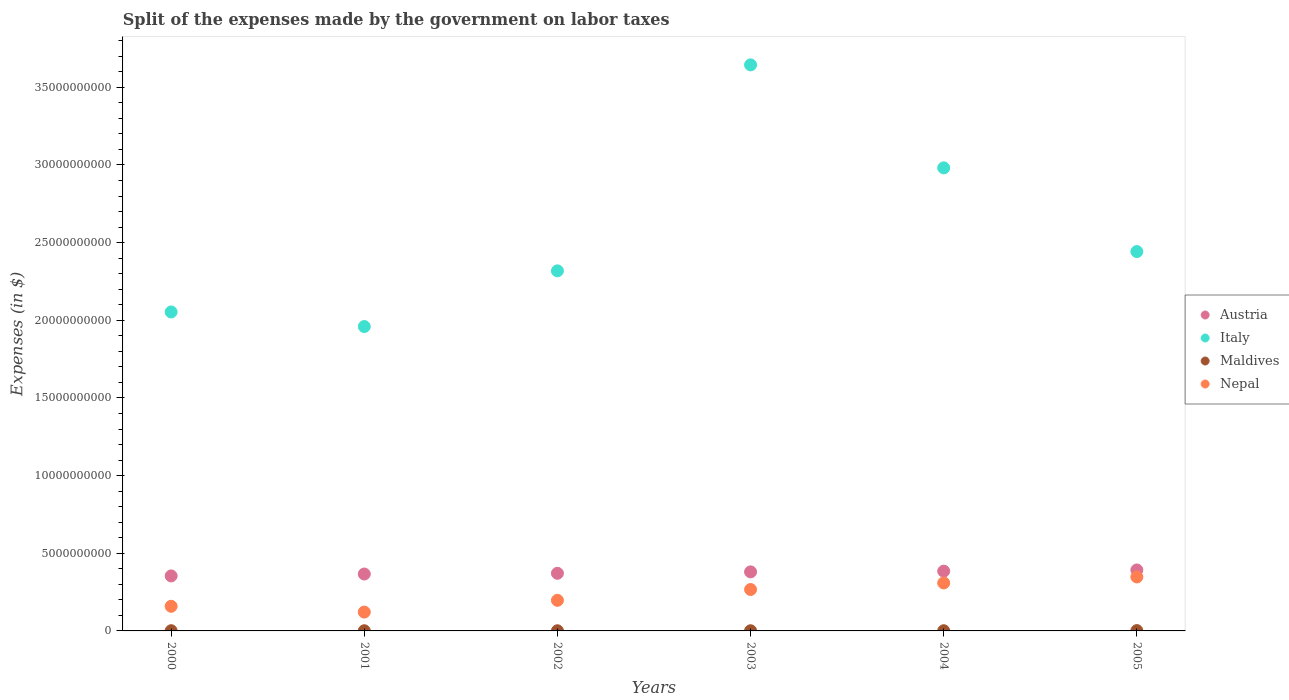How many different coloured dotlines are there?
Your answer should be very brief. 4. What is the expenses made by the government on labor taxes in Maldives in 2004?
Your answer should be compact. 1.22e+07. Across all years, what is the maximum expenses made by the government on labor taxes in Austria?
Offer a terse response. 3.93e+09. Across all years, what is the minimum expenses made by the government on labor taxes in Maldives?
Give a very brief answer. 1.01e+07. In which year was the expenses made by the government on labor taxes in Austria minimum?
Your answer should be very brief. 2000. What is the total expenses made by the government on labor taxes in Austria in the graph?
Your answer should be compact. 2.25e+1. What is the difference between the expenses made by the government on labor taxes in Maldives in 2004 and that in 2005?
Offer a terse response. -8.00e+06. What is the difference between the expenses made by the government on labor taxes in Italy in 2000 and the expenses made by the government on labor taxes in Maldives in 2001?
Offer a very short reply. 2.05e+1. What is the average expenses made by the government on labor taxes in Nepal per year?
Provide a short and direct response. 2.33e+09. In the year 2005, what is the difference between the expenses made by the government on labor taxes in Maldives and expenses made by the government on labor taxes in Nepal?
Ensure brevity in your answer.  -3.45e+09. In how many years, is the expenses made by the government on labor taxes in Austria greater than 12000000000 $?
Your answer should be very brief. 0. What is the ratio of the expenses made by the government on labor taxes in Austria in 2001 to that in 2002?
Make the answer very short. 0.99. Is the expenses made by the government on labor taxes in Italy in 2000 less than that in 2005?
Keep it short and to the point. Yes. What is the difference between the highest and the second highest expenses made by the government on labor taxes in Maldives?
Provide a short and direct response. 6.80e+06. What is the difference between the highest and the lowest expenses made by the government on labor taxes in Maldives?
Your answer should be very brief. 1.01e+07. In how many years, is the expenses made by the government on labor taxes in Nepal greater than the average expenses made by the government on labor taxes in Nepal taken over all years?
Provide a succinct answer. 3. Is it the case that in every year, the sum of the expenses made by the government on labor taxes in Maldives and expenses made by the government on labor taxes in Italy  is greater than the sum of expenses made by the government on labor taxes in Nepal and expenses made by the government on labor taxes in Austria?
Offer a terse response. Yes. Is it the case that in every year, the sum of the expenses made by the government on labor taxes in Austria and expenses made by the government on labor taxes in Italy  is greater than the expenses made by the government on labor taxes in Maldives?
Make the answer very short. Yes. Does the graph contain grids?
Provide a succinct answer. No. How are the legend labels stacked?
Give a very brief answer. Vertical. What is the title of the graph?
Provide a succinct answer. Split of the expenses made by the government on labor taxes. Does "Liechtenstein" appear as one of the legend labels in the graph?
Your answer should be very brief. No. What is the label or title of the X-axis?
Your response must be concise. Years. What is the label or title of the Y-axis?
Offer a very short reply. Expenses (in $). What is the Expenses (in $) of Austria in 2000?
Your answer should be compact. 3.54e+09. What is the Expenses (in $) of Italy in 2000?
Offer a very short reply. 2.05e+1. What is the Expenses (in $) of Maldives in 2000?
Your answer should be very brief. 1.34e+07. What is the Expenses (in $) of Nepal in 2000?
Your response must be concise. 1.59e+09. What is the Expenses (in $) of Austria in 2001?
Offer a terse response. 3.66e+09. What is the Expenses (in $) in Italy in 2001?
Your answer should be compact. 1.96e+1. What is the Expenses (in $) of Maldives in 2001?
Provide a succinct answer. 1.19e+07. What is the Expenses (in $) of Nepal in 2001?
Make the answer very short. 1.21e+09. What is the Expenses (in $) in Austria in 2002?
Your response must be concise. 3.71e+09. What is the Expenses (in $) in Italy in 2002?
Your answer should be compact. 2.32e+1. What is the Expenses (in $) in Maldives in 2002?
Give a very brief answer. 1.01e+07. What is the Expenses (in $) of Nepal in 2002?
Your answer should be very brief. 1.97e+09. What is the Expenses (in $) of Austria in 2003?
Keep it short and to the point. 3.80e+09. What is the Expenses (in $) of Italy in 2003?
Offer a terse response. 3.64e+1. What is the Expenses (in $) in Maldives in 2003?
Keep it short and to the point. 1.06e+07. What is the Expenses (in $) in Nepal in 2003?
Make the answer very short. 2.67e+09. What is the Expenses (in $) in Austria in 2004?
Offer a terse response. 3.85e+09. What is the Expenses (in $) in Italy in 2004?
Your answer should be compact. 2.98e+1. What is the Expenses (in $) in Maldives in 2004?
Provide a succinct answer. 1.22e+07. What is the Expenses (in $) in Nepal in 2004?
Offer a terse response. 3.09e+09. What is the Expenses (in $) in Austria in 2005?
Your answer should be compact. 3.93e+09. What is the Expenses (in $) in Italy in 2005?
Offer a terse response. 2.44e+1. What is the Expenses (in $) in Maldives in 2005?
Keep it short and to the point. 2.02e+07. What is the Expenses (in $) in Nepal in 2005?
Provide a short and direct response. 3.48e+09. Across all years, what is the maximum Expenses (in $) in Austria?
Your response must be concise. 3.93e+09. Across all years, what is the maximum Expenses (in $) in Italy?
Your answer should be compact. 3.64e+1. Across all years, what is the maximum Expenses (in $) in Maldives?
Ensure brevity in your answer.  2.02e+07. Across all years, what is the maximum Expenses (in $) of Nepal?
Offer a very short reply. 3.48e+09. Across all years, what is the minimum Expenses (in $) in Austria?
Keep it short and to the point. 3.54e+09. Across all years, what is the minimum Expenses (in $) of Italy?
Offer a terse response. 1.96e+1. Across all years, what is the minimum Expenses (in $) of Maldives?
Give a very brief answer. 1.01e+07. Across all years, what is the minimum Expenses (in $) of Nepal?
Offer a very short reply. 1.21e+09. What is the total Expenses (in $) in Austria in the graph?
Make the answer very short. 2.25e+1. What is the total Expenses (in $) in Italy in the graph?
Offer a very short reply. 1.54e+11. What is the total Expenses (in $) in Maldives in the graph?
Offer a terse response. 7.84e+07. What is the total Expenses (in $) of Nepal in the graph?
Your response must be concise. 1.40e+1. What is the difference between the Expenses (in $) in Austria in 2000 and that in 2001?
Ensure brevity in your answer.  -1.22e+08. What is the difference between the Expenses (in $) of Italy in 2000 and that in 2001?
Offer a terse response. 9.39e+08. What is the difference between the Expenses (in $) in Maldives in 2000 and that in 2001?
Offer a very short reply. 1.50e+06. What is the difference between the Expenses (in $) of Nepal in 2000 and that in 2001?
Your response must be concise. 3.73e+08. What is the difference between the Expenses (in $) in Austria in 2000 and that in 2002?
Offer a terse response. -1.69e+08. What is the difference between the Expenses (in $) in Italy in 2000 and that in 2002?
Your answer should be very brief. -2.65e+09. What is the difference between the Expenses (in $) of Maldives in 2000 and that in 2002?
Provide a short and direct response. 3.30e+06. What is the difference between the Expenses (in $) in Nepal in 2000 and that in 2002?
Your answer should be very brief. -3.84e+08. What is the difference between the Expenses (in $) in Austria in 2000 and that in 2003?
Keep it short and to the point. -2.60e+08. What is the difference between the Expenses (in $) in Italy in 2000 and that in 2003?
Offer a very short reply. -1.59e+1. What is the difference between the Expenses (in $) of Maldives in 2000 and that in 2003?
Keep it short and to the point. 2.80e+06. What is the difference between the Expenses (in $) of Nepal in 2000 and that in 2003?
Offer a very short reply. -1.08e+09. What is the difference between the Expenses (in $) in Austria in 2000 and that in 2004?
Your response must be concise. -3.06e+08. What is the difference between the Expenses (in $) of Italy in 2000 and that in 2004?
Your answer should be compact. -9.28e+09. What is the difference between the Expenses (in $) of Maldives in 2000 and that in 2004?
Your answer should be very brief. 1.20e+06. What is the difference between the Expenses (in $) in Nepal in 2000 and that in 2004?
Provide a succinct answer. -1.50e+09. What is the difference between the Expenses (in $) of Austria in 2000 and that in 2005?
Ensure brevity in your answer.  -3.83e+08. What is the difference between the Expenses (in $) of Italy in 2000 and that in 2005?
Your answer should be very brief. -3.89e+09. What is the difference between the Expenses (in $) of Maldives in 2000 and that in 2005?
Offer a very short reply. -6.80e+06. What is the difference between the Expenses (in $) of Nepal in 2000 and that in 2005?
Offer a very short reply. -1.89e+09. What is the difference between the Expenses (in $) of Austria in 2001 and that in 2002?
Make the answer very short. -4.68e+07. What is the difference between the Expenses (in $) in Italy in 2001 and that in 2002?
Provide a short and direct response. -3.59e+09. What is the difference between the Expenses (in $) of Maldives in 2001 and that in 2002?
Provide a succinct answer. 1.80e+06. What is the difference between the Expenses (in $) of Nepal in 2001 and that in 2002?
Your answer should be compact. -7.57e+08. What is the difference between the Expenses (in $) in Austria in 2001 and that in 2003?
Offer a very short reply. -1.38e+08. What is the difference between the Expenses (in $) of Italy in 2001 and that in 2003?
Your answer should be very brief. -1.68e+1. What is the difference between the Expenses (in $) in Maldives in 2001 and that in 2003?
Ensure brevity in your answer.  1.30e+06. What is the difference between the Expenses (in $) in Nepal in 2001 and that in 2003?
Provide a succinct answer. -1.45e+09. What is the difference between the Expenses (in $) in Austria in 2001 and that in 2004?
Your response must be concise. -1.85e+08. What is the difference between the Expenses (in $) in Italy in 2001 and that in 2004?
Provide a short and direct response. -1.02e+1. What is the difference between the Expenses (in $) in Maldives in 2001 and that in 2004?
Provide a succinct answer. -3.00e+05. What is the difference between the Expenses (in $) of Nepal in 2001 and that in 2004?
Your answer should be compact. -1.88e+09. What is the difference between the Expenses (in $) of Austria in 2001 and that in 2005?
Ensure brevity in your answer.  -2.61e+08. What is the difference between the Expenses (in $) in Italy in 2001 and that in 2005?
Keep it short and to the point. -4.83e+09. What is the difference between the Expenses (in $) of Maldives in 2001 and that in 2005?
Keep it short and to the point. -8.30e+06. What is the difference between the Expenses (in $) in Nepal in 2001 and that in 2005?
Provide a succinct answer. -2.26e+09. What is the difference between the Expenses (in $) of Austria in 2002 and that in 2003?
Provide a short and direct response. -9.16e+07. What is the difference between the Expenses (in $) in Italy in 2002 and that in 2003?
Provide a short and direct response. -1.33e+1. What is the difference between the Expenses (in $) of Maldives in 2002 and that in 2003?
Give a very brief answer. -5.00e+05. What is the difference between the Expenses (in $) of Nepal in 2002 and that in 2003?
Your answer should be very brief. -6.97e+08. What is the difference between the Expenses (in $) of Austria in 2002 and that in 2004?
Ensure brevity in your answer.  -1.38e+08. What is the difference between the Expenses (in $) of Italy in 2002 and that in 2004?
Your answer should be very brief. -6.63e+09. What is the difference between the Expenses (in $) of Maldives in 2002 and that in 2004?
Your response must be concise. -2.10e+06. What is the difference between the Expenses (in $) of Nepal in 2002 and that in 2004?
Ensure brevity in your answer.  -1.12e+09. What is the difference between the Expenses (in $) of Austria in 2002 and that in 2005?
Keep it short and to the point. -2.15e+08. What is the difference between the Expenses (in $) of Italy in 2002 and that in 2005?
Ensure brevity in your answer.  -1.24e+09. What is the difference between the Expenses (in $) in Maldives in 2002 and that in 2005?
Your response must be concise. -1.01e+07. What is the difference between the Expenses (in $) of Nepal in 2002 and that in 2005?
Your answer should be compact. -1.51e+09. What is the difference between the Expenses (in $) in Austria in 2003 and that in 2004?
Make the answer very short. -4.63e+07. What is the difference between the Expenses (in $) of Italy in 2003 and that in 2004?
Make the answer very short. 6.63e+09. What is the difference between the Expenses (in $) of Maldives in 2003 and that in 2004?
Offer a terse response. -1.60e+06. What is the difference between the Expenses (in $) of Nepal in 2003 and that in 2004?
Keep it short and to the point. -4.22e+08. What is the difference between the Expenses (in $) of Austria in 2003 and that in 2005?
Your answer should be very brief. -1.23e+08. What is the difference between the Expenses (in $) of Italy in 2003 and that in 2005?
Your answer should be very brief. 1.20e+1. What is the difference between the Expenses (in $) in Maldives in 2003 and that in 2005?
Your response must be concise. -9.60e+06. What is the difference between the Expenses (in $) in Nepal in 2003 and that in 2005?
Keep it short and to the point. -8.08e+08. What is the difference between the Expenses (in $) of Austria in 2004 and that in 2005?
Give a very brief answer. -7.66e+07. What is the difference between the Expenses (in $) of Italy in 2004 and that in 2005?
Offer a terse response. 5.39e+09. What is the difference between the Expenses (in $) in Maldives in 2004 and that in 2005?
Your answer should be compact. -8.00e+06. What is the difference between the Expenses (in $) in Nepal in 2004 and that in 2005?
Offer a terse response. -3.86e+08. What is the difference between the Expenses (in $) of Austria in 2000 and the Expenses (in $) of Italy in 2001?
Provide a short and direct response. -1.61e+1. What is the difference between the Expenses (in $) in Austria in 2000 and the Expenses (in $) in Maldives in 2001?
Provide a succinct answer. 3.53e+09. What is the difference between the Expenses (in $) of Austria in 2000 and the Expenses (in $) of Nepal in 2001?
Keep it short and to the point. 2.33e+09. What is the difference between the Expenses (in $) in Italy in 2000 and the Expenses (in $) in Maldives in 2001?
Offer a terse response. 2.05e+1. What is the difference between the Expenses (in $) of Italy in 2000 and the Expenses (in $) of Nepal in 2001?
Offer a very short reply. 1.93e+1. What is the difference between the Expenses (in $) of Maldives in 2000 and the Expenses (in $) of Nepal in 2001?
Ensure brevity in your answer.  -1.20e+09. What is the difference between the Expenses (in $) of Austria in 2000 and the Expenses (in $) of Italy in 2002?
Ensure brevity in your answer.  -1.96e+1. What is the difference between the Expenses (in $) of Austria in 2000 and the Expenses (in $) of Maldives in 2002?
Provide a short and direct response. 3.53e+09. What is the difference between the Expenses (in $) of Austria in 2000 and the Expenses (in $) of Nepal in 2002?
Keep it short and to the point. 1.57e+09. What is the difference between the Expenses (in $) in Italy in 2000 and the Expenses (in $) in Maldives in 2002?
Your answer should be compact. 2.05e+1. What is the difference between the Expenses (in $) of Italy in 2000 and the Expenses (in $) of Nepal in 2002?
Your answer should be compact. 1.86e+1. What is the difference between the Expenses (in $) in Maldives in 2000 and the Expenses (in $) in Nepal in 2002?
Make the answer very short. -1.96e+09. What is the difference between the Expenses (in $) in Austria in 2000 and the Expenses (in $) in Italy in 2003?
Keep it short and to the point. -3.29e+1. What is the difference between the Expenses (in $) in Austria in 2000 and the Expenses (in $) in Maldives in 2003?
Your answer should be compact. 3.53e+09. What is the difference between the Expenses (in $) in Austria in 2000 and the Expenses (in $) in Nepal in 2003?
Make the answer very short. 8.75e+08. What is the difference between the Expenses (in $) in Italy in 2000 and the Expenses (in $) in Maldives in 2003?
Your answer should be very brief. 2.05e+1. What is the difference between the Expenses (in $) in Italy in 2000 and the Expenses (in $) in Nepal in 2003?
Make the answer very short. 1.79e+1. What is the difference between the Expenses (in $) in Maldives in 2000 and the Expenses (in $) in Nepal in 2003?
Give a very brief answer. -2.65e+09. What is the difference between the Expenses (in $) of Austria in 2000 and the Expenses (in $) of Italy in 2004?
Your answer should be compact. -2.63e+1. What is the difference between the Expenses (in $) of Austria in 2000 and the Expenses (in $) of Maldives in 2004?
Your answer should be compact. 3.53e+09. What is the difference between the Expenses (in $) of Austria in 2000 and the Expenses (in $) of Nepal in 2004?
Offer a terse response. 4.53e+08. What is the difference between the Expenses (in $) of Italy in 2000 and the Expenses (in $) of Maldives in 2004?
Provide a succinct answer. 2.05e+1. What is the difference between the Expenses (in $) in Italy in 2000 and the Expenses (in $) in Nepal in 2004?
Offer a terse response. 1.74e+1. What is the difference between the Expenses (in $) of Maldives in 2000 and the Expenses (in $) of Nepal in 2004?
Give a very brief answer. -3.08e+09. What is the difference between the Expenses (in $) in Austria in 2000 and the Expenses (in $) in Italy in 2005?
Your response must be concise. -2.09e+1. What is the difference between the Expenses (in $) of Austria in 2000 and the Expenses (in $) of Maldives in 2005?
Your answer should be compact. 3.52e+09. What is the difference between the Expenses (in $) of Austria in 2000 and the Expenses (in $) of Nepal in 2005?
Provide a succinct answer. 6.69e+07. What is the difference between the Expenses (in $) of Italy in 2000 and the Expenses (in $) of Maldives in 2005?
Your response must be concise. 2.05e+1. What is the difference between the Expenses (in $) of Italy in 2000 and the Expenses (in $) of Nepal in 2005?
Give a very brief answer. 1.71e+1. What is the difference between the Expenses (in $) of Maldives in 2000 and the Expenses (in $) of Nepal in 2005?
Offer a very short reply. -3.46e+09. What is the difference between the Expenses (in $) of Austria in 2001 and the Expenses (in $) of Italy in 2002?
Your answer should be compact. -1.95e+1. What is the difference between the Expenses (in $) in Austria in 2001 and the Expenses (in $) in Maldives in 2002?
Your answer should be compact. 3.65e+09. What is the difference between the Expenses (in $) of Austria in 2001 and the Expenses (in $) of Nepal in 2002?
Offer a terse response. 1.69e+09. What is the difference between the Expenses (in $) in Italy in 2001 and the Expenses (in $) in Maldives in 2002?
Your response must be concise. 1.96e+1. What is the difference between the Expenses (in $) of Italy in 2001 and the Expenses (in $) of Nepal in 2002?
Your answer should be compact. 1.76e+1. What is the difference between the Expenses (in $) in Maldives in 2001 and the Expenses (in $) in Nepal in 2002?
Offer a very short reply. -1.96e+09. What is the difference between the Expenses (in $) in Austria in 2001 and the Expenses (in $) in Italy in 2003?
Offer a very short reply. -3.28e+1. What is the difference between the Expenses (in $) of Austria in 2001 and the Expenses (in $) of Maldives in 2003?
Your answer should be very brief. 3.65e+09. What is the difference between the Expenses (in $) in Austria in 2001 and the Expenses (in $) in Nepal in 2003?
Offer a very short reply. 9.97e+08. What is the difference between the Expenses (in $) in Italy in 2001 and the Expenses (in $) in Maldives in 2003?
Provide a succinct answer. 1.96e+1. What is the difference between the Expenses (in $) in Italy in 2001 and the Expenses (in $) in Nepal in 2003?
Offer a terse response. 1.69e+1. What is the difference between the Expenses (in $) of Maldives in 2001 and the Expenses (in $) of Nepal in 2003?
Your answer should be compact. -2.66e+09. What is the difference between the Expenses (in $) in Austria in 2001 and the Expenses (in $) in Italy in 2004?
Your answer should be very brief. -2.62e+1. What is the difference between the Expenses (in $) in Austria in 2001 and the Expenses (in $) in Maldives in 2004?
Ensure brevity in your answer.  3.65e+09. What is the difference between the Expenses (in $) in Austria in 2001 and the Expenses (in $) in Nepal in 2004?
Provide a succinct answer. 5.75e+08. What is the difference between the Expenses (in $) of Italy in 2001 and the Expenses (in $) of Maldives in 2004?
Ensure brevity in your answer.  1.96e+1. What is the difference between the Expenses (in $) of Italy in 2001 and the Expenses (in $) of Nepal in 2004?
Offer a very short reply. 1.65e+1. What is the difference between the Expenses (in $) of Maldives in 2001 and the Expenses (in $) of Nepal in 2004?
Keep it short and to the point. -3.08e+09. What is the difference between the Expenses (in $) of Austria in 2001 and the Expenses (in $) of Italy in 2005?
Give a very brief answer. -2.08e+1. What is the difference between the Expenses (in $) of Austria in 2001 and the Expenses (in $) of Maldives in 2005?
Make the answer very short. 3.64e+09. What is the difference between the Expenses (in $) in Austria in 2001 and the Expenses (in $) in Nepal in 2005?
Your answer should be very brief. 1.89e+08. What is the difference between the Expenses (in $) in Italy in 2001 and the Expenses (in $) in Maldives in 2005?
Make the answer very short. 1.96e+1. What is the difference between the Expenses (in $) of Italy in 2001 and the Expenses (in $) of Nepal in 2005?
Make the answer very short. 1.61e+1. What is the difference between the Expenses (in $) of Maldives in 2001 and the Expenses (in $) of Nepal in 2005?
Offer a terse response. -3.46e+09. What is the difference between the Expenses (in $) in Austria in 2002 and the Expenses (in $) in Italy in 2003?
Ensure brevity in your answer.  -3.27e+1. What is the difference between the Expenses (in $) of Austria in 2002 and the Expenses (in $) of Maldives in 2003?
Provide a succinct answer. 3.70e+09. What is the difference between the Expenses (in $) of Austria in 2002 and the Expenses (in $) of Nepal in 2003?
Keep it short and to the point. 1.04e+09. What is the difference between the Expenses (in $) of Italy in 2002 and the Expenses (in $) of Maldives in 2003?
Your response must be concise. 2.32e+1. What is the difference between the Expenses (in $) of Italy in 2002 and the Expenses (in $) of Nepal in 2003?
Your response must be concise. 2.05e+1. What is the difference between the Expenses (in $) in Maldives in 2002 and the Expenses (in $) in Nepal in 2003?
Keep it short and to the point. -2.66e+09. What is the difference between the Expenses (in $) of Austria in 2002 and the Expenses (in $) of Italy in 2004?
Ensure brevity in your answer.  -2.61e+1. What is the difference between the Expenses (in $) in Austria in 2002 and the Expenses (in $) in Maldives in 2004?
Ensure brevity in your answer.  3.70e+09. What is the difference between the Expenses (in $) of Austria in 2002 and the Expenses (in $) of Nepal in 2004?
Ensure brevity in your answer.  6.22e+08. What is the difference between the Expenses (in $) of Italy in 2002 and the Expenses (in $) of Maldives in 2004?
Your response must be concise. 2.32e+1. What is the difference between the Expenses (in $) in Italy in 2002 and the Expenses (in $) in Nepal in 2004?
Keep it short and to the point. 2.01e+1. What is the difference between the Expenses (in $) in Maldives in 2002 and the Expenses (in $) in Nepal in 2004?
Give a very brief answer. -3.08e+09. What is the difference between the Expenses (in $) of Austria in 2002 and the Expenses (in $) of Italy in 2005?
Provide a short and direct response. -2.07e+1. What is the difference between the Expenses (in $) of Austria in 2002 and the Expenses (in $) of Maldives in 2005?
Provide a succinct answer. 3.69e+09. What is the difference between the Expenses (in $) in Austria in 2002 and the Expenses (in $) in Nepal in 2005?
Your response must be concise. 2.35e+08. What is the difference between the Expenses (in $) of Italy in 2002 and the Expenses (in $) of Maldives in 2005?
Give a very brief answer. 2.32e+1. What is the difference between the Expenses (in $) of Italy in 2002 and the Expenses (in $) of Nepal in 2005?
Keep it short and to the point. 1.97e+1. What is the difference between the Expenses (in $) of Maldives in 2002 and the Expenses (in $) of Nepal in 2005?
Your answer should be very brief. -3.46e+09. What is the difference between the Expenses (in $) of Austria in 2003 and the Expenses (in $) of Italy in 2004?
Offer a very short reply. -2.60e+1. What is the difference between the Expenses (in $) of Austria in 2003 and the Expenses (in $) of Maldives in 2004?
Offer a terse response. 3.79e+09. What is the difference between the Expenses (in $) in Austria in 2003 and the Expenses (in $) in Nepal in 2004?
Offer a very short reply. 7.13e+08. What is the difference between the Expenses (in $) of Italy in 2003 and the Expenses (in $) of Maldives in 2004?
Your answer should be very brief. 3.64e+1. What is the difference between the Expenses (in $) in Italy in 2003 and the Expenses (in $) in Nepal in 2004?
Your response must be concise. 3.34e+1. What is the difference between the Expenses (in $) of Maldives in 2003 and the Expenses (in $) of Nepal in 2004?
Give a very brief answer. -3.08e+09. What is the difference between the Expenses (in $) in Austria in 2003 and the Expenses (in $) in Italy in 2005?
Keep it short and to the point. -2.06e+1. What is the difference between the Expenses (in $) of Austria in 2003 and the Expenses (in $) of Maldives in 2005?
Offer a terse response. 3.78e+09. What is the difference between the Expenses (in $) of Austria in 2003 and the Expenses (in $) of Nepal in 2005?
Provide a short and direct response. 3.27e+08. What is the difference between the Expenses (in $) in Italy in 2003 and the Expenses (in $) in Maldives in 2005?
Your answer should be very brief. 3.64e+1. What is the difference between the Expenses (in $) in Italy in 2003 and the Expenses (in $) in Nepal in 2005?
Your answer should be compact. 3.30e+1. What is the difference between the Expenses (in $) of Maldives in 2003 and the Expenses (in $) of Nepal in 2005?
Give a very brief answer. -3.46e+09. What is the difference between the Expenses (in $) in Austria in 2004 and the Expenses (in $) in Italy in 2005?
Your answer should be very brief. -2.06e+1. What is the difference between the Expenses (in $) in Austria in 2004 and the Expenses (in $) in Maldives in 2005?
Provide a short and direct response. 3.83e+09. What is the difference between the Expenses (in $) in Austria in 2004 and the Expenses (in $) in Nepal in 2005?
Offer a terse response. 3.73e+08. What is the difference between the Expenses (in $) of Italy in 2004 and the Expenses (in $) of Maldives in 2005?
Your answer should be very brief. 2.98e+1. What is the difference between the Expenses (in $) of Italy in 2004 and the Expenses (in $) of Nepal in 2005?
Ensure brevity in your answer.  2.63e+1. What is the difference between the Expenses (in $) in Maldives in 2004 and the Expenses (in $) in Nepal in 2005?
Provide a succinct answer. -3.46e+09. What is the average Expenses (in $) in Austria per year?
Offer a very short reply. 3.75e+09. What is the average Expenses (in $) of Italy per year?
Provide a short and direct response. 2.57e+1. What is the average Expenses (in $) in Maldives per year?
Make the answer very short. 1.31e+07. What is the average Expenses (in $) in Nepal per year?
Your answer should be very brief. 2.33e+09. In the year 2000, what is the difference between the Expenses (in $) of Austria and Expenses (in $) of Italy?
Give a very brief answer. -1.70e+1. In the year 2000, what is the difference between the Expenses (in $) of Austria and Expenses (in $) of Maldives?
Make the answer very short. 3.53e+09. In the year 2000, what is the difference between the Expenses (in $) of Austria and Expenses (in $) of Nepal?
Keep it short and to the point. 1.96e+09. In the year 2000, what is the difference between the Expenses (in $) of Italy and Expenses (in $) of Maldives?
Your response must be concise. 2.05e+1. In the year 2000, what is the difference between the Expenses (in $) of Italy and Expenses (in $) of Nepal?
Your answer should be very brief. 1.90e+1. In the year 2000, what is the difference between the Expenses (in $) in Maldives and Expenses (in $) in Nepal?
Provide a succinct answer. -1.57e+09. In the year 2001, what is the difference between the Expenses (in $) in Austria and Expenses (in $) in Italy?
Provide a short and direct response. -1.59e+1. In the year 2001, what is the difference between the Expenses (in $) of Austria and Expenses (in $) of Maldives?
Give a very brief answer. 3.65e+09. In the year 2001, what is the difference between the Expenses (in $) of Austria and Expenses (in $) of Nepal?
Your response must be concise. 2.45e+09. In the year 2001, what is the difference between the Expenses (in $) in Italy and Expenses (in $) in Maldives?
Give a very brief answer. 1.96e+1. In the year 2001, what is the difference between the Expenses (in $) of Italy and Expenses (in $) of Nepal?
Offer a very short reply. 1.84e+1. In the year 2001, what is the difference between the Expenses (in $) in Maldives and Expenses (in $) in Nepal?
Keep it short and to the point. -1.20e+09. In the year 2002, what is the difference between the Expenses (in $) of Austria and Expenses (in $) of Italy?
Offer a terse response. -1.95e+1. In the year 2002, what is the difference between the Expenses (in $) of Austria and Expenses (in $) of Maldives?
Provide a succinct answer. 3.70e+09. In the year 2002, what is the difference between the Expenses (in $) in Austria and Expenses (in $) in Nepal?
Your answer should be compact. 1.74e+09. In the year 2002, what is the difference between the Expenses (in $) of Italy and Expenses (in $) of Maldives?
Provide a short and direct response. 2.32e+1. In the year 2002, what is the difference between the Expenses (in $) in Italy and Expenses (in $) in Nepal?
Your answer should be compact. 2.12e+1. In the year 2002, what is the difference between the Expenses (in $) in Maldives and Expenses (in $) in Nepal?
Keep it short and to the point. -1.96e+09. In the year 2003, what is the difference between the Expenses (in $) in Austria and Expenses (in $) in Italy?
Ensure brevity in your answer.  -3.26e+1. In the year 2003, what is the difference between the Expenses (in $) of Austria and Expenses (in $) of Maldives?
Offer a terse response. 3.79e+09. In the year 2003, what is the difference between the Expenses (in $) in Austria and Expenses (in $) in Nepal?
Give a very brief answer. 1.14e+09. In the year 2003, what is the difference between the Expenses (in $) of Italy and Expenses (in $) of Maldives?
Offer a terse response. 3.64e+1. In the year 2003, what is the difference between the Expenses (in $) in Italy and Expenses (in $) in Nepal?
Offer a terse response. 3.38e+1. In the year 2003, what is the difference between the Expenses (in $) in Maldives and Expenses (in $) in Nepal?
Your response must be concise. -2.66e+09. In the year 2004, what is the difference between the Expenses (in $) of Austria and Expenses (in $) of Italy?
Offer a very short reply. -2.60e+1. In the year 2004, what is the difference between the Expenses (in $) of Austria and Expenses (in $) of Maldives?
Your response must be concise. 3.84e+09. In the year 2004, what is the difference between the Expenses (in $) of Austria and Expenses (in $) of Nepal?
Give a very brief answer. 7.60e+08. In the year 2004, what is the difference between the Expenses (in $) in Italy and Expenses (in $) in Maldives?
Keep it short and to the point. 2.98e+1. In the year 2004, what is the difference between the Expenses (in $) in Italy and Expenses (in $) in Nepal?
Provide a short and direct response. 2.67e+1. In the year 2004, what is the difference between the Expenses (in $) of Maldives and Expenses (in $) of Nepal?
Provide a succinct answer. -3.08e+09. In the year 2005, what is the difference between the Expenses (in $) of Austria and Expenses (in $) of Italy?
Ensure brevity in your answer.  -2.05e+1. In the year 2005, what is the difference between the Expenses (in $) of Austria and Expenses (in $) of Maldives?
Make the answer very short. 3.90e+09. In the year 2005, what is the difference between the Expenses (in $) in Austria and Expenses (in $) in Nepal?
Ensure brevity in your answer.  4.50e+08. In the year 2005, what is the difference between the Expenses (in $) of Italy and Expenses (in $) of Maldives?
Your response must be concise. 2.44e+1. In the year 2005, what is the difference between the Expenses (in $) in Italy and Expenses (in $) in Nepal?
Offer a terse response. 2.09e+1. In the year 2005, what is the difference between the Expenses (in $) in Maldives and Expenses (in $) in Nepal?
Ensure brevity in your answer.  -3.45e+09. What is the ratio of the Expenses (in $) in Austria in 2000 to that in 2001?
Provide a succinct answer. 0.97. What is the ratio of the Expenses (in $) of Italy in 2000 to that in 2001?
Keep it short and to the point. 1.05. What is the ratio of the Expenses (in $) in Maldives in 2000 to that in 2001?
Ensure brevity in your answer.  1.13. What is the ratio of the Expenses (in $) of Nepal in 2000 to that in 2001?
Provide a succinct answer. 1.31. What is the ratio of the Expenses (in $) in Austria in 2000 to that in 2002?
Your answer should be very brief. 0.95. What is the ratio of the Expenses (in $) of Italy in 2000 to that in 2002?
Your answer should be very brief. 0.89. What is the ratio of the Expenses (in $) in Maldives in 2000 to that in 2002?
Ensure brevity in your answer.  1.33. What is the ratio of the Expenses (in $) of Nepal in 2000 to that in 2002?
Make the answer very short. 0.81. What is the ratio of the Expenses (in $) in Austria in 2000 to that in 2003?
Make the answer very short. 0.93. What is the ratio of the Expenses (in $) in Italy in 2000 to that in 2003?
Offer a very short reply. 0.56. What is the ratio of the Expenses (in $) of Maldives in 2000 to that in 2003?
Offer a very short reply. 1.26. What is the ratio of the Expenses (in $) of Nepal in 2000 to that in 2003?
Your answer should be compact. 0.59. What is the ratio of the Expenses (in $) in Austria in 2000 to that in 2004?
Provide a short and direct response. 0.92. What is the ratio of the Expenses (in $) of Italy in 2000 to that in 2004?
Ensure brevity in your answer.  0.69. What is the ratio of the Expenses (in $) in Maldives in 2000 to that in 2004?
Offer a very short reply. 1.1. What is the ratio of the Expenses (in $) in Nepal in 2000 to that in 2004?
Your answer should be very brief. 0.51. What is the ratio of the Expenses (in $) in Austria in 2000 to that in 2005?
Keep it short and to the point. 0.9. What is the ratio of the Expenses (in $) of Italy in 2000 to that in 2005?
Your answer should be very brief. 0.84. What is the ratio of the Expenses (in $) of Maldives in 2000 to that in 2005?
Make the answer very short. 0.66. What is the ratio of the Expenses (in $) of Nepal in 2000 to that in 2005?
Your response must be concise. 0.46. What is the ratio of the Expenses (in $) of Austria in 2001 to that in 2002?
Provide a short and direct response. 0.99. What is the ratio of the Expenses (in $) of Italy in 2001 to that in 2002?
Give a very brief answer. 0.85. What is the ratio of the Expenses (in $) in Maldives in 2001 to that in 2002?
Keep it short and to the point. 1.18. What is the ratio of the Expenses (in $) in Nepal in 2001 to that in 2002?
Give a very brief answer. 0.62. What is the ratio of the Expenses (in $) in Austria in 2001 to that in 2003?
Your response must be concise. 0.96. What is the ratio of the Expenses (in $) of Italy in 2001 to that in 2003?
Your answer should be very brief. 0.54. What is the ratio of the Expenses (in $) in Maldives in 2001 to that in 2003?
Your answer should be compact. 1.12. What is the ratio of the Expenses (in $) of Nepal in 2001 to that in 2003?
Offer a very short reply. 0.45. What is the ratio of the Expenses (in $) of Italy in 2001 to that in 2004?
Offer a very short reply. 0.66. What is the ratio of the Expenses (in $) in Maldives in 2001 to that in 2004?
Keep it short and to the point. 0.98. What is the ratio of the Expenses (in $) of Nepal in 2001 to that in 2004?
Give a very brief answer. 0.39. What is the ratio of the Expenses (in $) in Austria in 2001 to that in 2005?
Offer a terse response. 0.93. What is the ratio of the Expenses (in $) in Italy in 2001 to that in 2005?
Ensure brevity in your answer.  0.8. What is the ratio of the Expenses (in $) of Maldives in 2001 to that in 2005?
Keep it short and to the point. 0.59. What is the ratio of the Expenses (in $) of Nepal in 2001 to that in 2005?
Ensure brevity in your answer.  0.35. What is the ratio of the Expenses (in $) in Austria in 2002 to that in 2003?
Your response must be concise. 0.98. What is the ratio of the Expenses (in $) in Italy in 2002 to that in 2003?
Your answer should be compact. 0.64. What is the ratio of the Expenses (in $) of Maldives in 2002 to that in 2003?
Ensure brevity in your answer.  0.95. What is the ratio of the Expenses (in $) of Nepal in 2002 to that in 2003?
Your answer should be compact. 0.74. What is the ratio of the Expenses (in $) of Austria in 2002 to that in 2004?
Provide a succinct answer. 0.96. What is the ratio of the Expenses (in $) of Italy in 2002 to that in 2004?
Keep it short and to the point. 0.78. What is the ratio of the Expenses (in $) of Maldives in 2002 to that in 2004?
Your answer should be very brief. 0.83. What is the ratio of the Expenses (in $) in Nepal in 2002 to that in 2004?
Provide a succinct answer. 0.64. What is the ratio of the Expenses (in $) of Austria in 2002 to that in 2005?
Keep it short and to the point. 0.95. What is the ratio of the Expenses (in $) in Italy in 2002 to that in 2005?
Your answer should be compact. 0.95. What is the ratio of the Expenses (in $) in Maldives in 2002 to that in 2005?
Offer a very short reply. 0.5. What is the ratio of the Expenses (in $) of Nepal in 2002 to that in 2005?
Offer a very short reply. 0.57. What is the ratio of the Expenses (in $) of Italy in 2003 to that in 2004?
Give a very brief answer. 1.22. What is the ratio of the Expenses (in $) of Maldives in 2003 to that in 2004?
Give a very brief answer. 0.87. What is the ratio of the Expenses (in $) of Nepal in 2003 to that in 2004?
Offer a terse response. 0.86. What is the ratio of the Expenses (in $) of Austria in 2003 to that in 2005?
Your answer should be very brief. 0.97. What is the ratio of the Expenses (in $) in Italy in 2003 to that in 2005?
Provide a succinct answer. 1.49. What is the ratio of the Expenses (in $) of Maldives in 2003 to that in 2005?
Make the answer very short. 0.52. What is the ratio of the Expenses (in $) in Nepal in 2003 to that in 2005?
Your answer should be very brief. 0.77. What is the ratio of the Expenses (in $) in Austria in 2004 to that in 2005?
Make the answer very short. 0.98. What is the ratio of the Expenses (in $) of Italy in 2004 to that in 2005?
Provide a short and direct response. 1.22. What is the ratio of the Expenses (in $) of Maldives in 2004 to that in 2005?
Your answer should be very brief. 0.6. What is the ratio of the Expenses (in $) in Nepal in 2004 to that in 2005?
Your answer should be compact. 0.89. What is the difference between the highest and the second highest Expenses (in $) in Austria?
Offer a terse response. 7.66e+07. What is the difference between the highest and the second highest Expenses (in $) in Italy?
Offer a terse response. 6.63e+09. What is the difference between the highest and the second highest Expenses (in $) of Maldives?
Offer a very short reply. 6.80e+06. What is the difference between the highest and the second highest Expenses (in $) in Nepal?
Provide a short and direct response. 3.86e+08. What is the difference between the highest and the lowest Expenses (in $) of Austria?
Give a very brief answer. 3.83e+08. What is the difference between the highest and the lowest Expenses (in $) in Italy?
Provide a succinct answer. 1.68e+1. What is the difference between the highest and the lowest Expenses (in $) in Maldives?
Your answer should be very brief. 1.01e+07. What is the difference between the highest and the lowest Expenses (in $) of Nepal?
Give a very brief answer. 2.26e+09. 